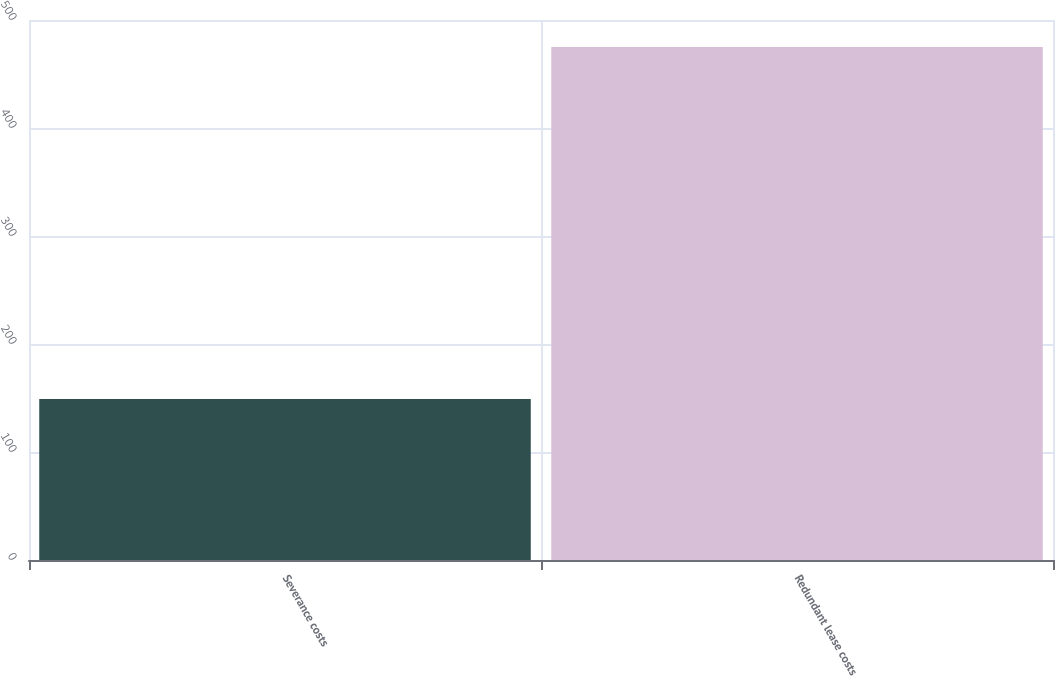Convert chart. <chart><loc_0><loc_0><loc_500><loc_500><bar_chart><fcel>Severance costs<fcel>Redundant lease costs<nl><fcel>149<fcel>475<nl></chart> 